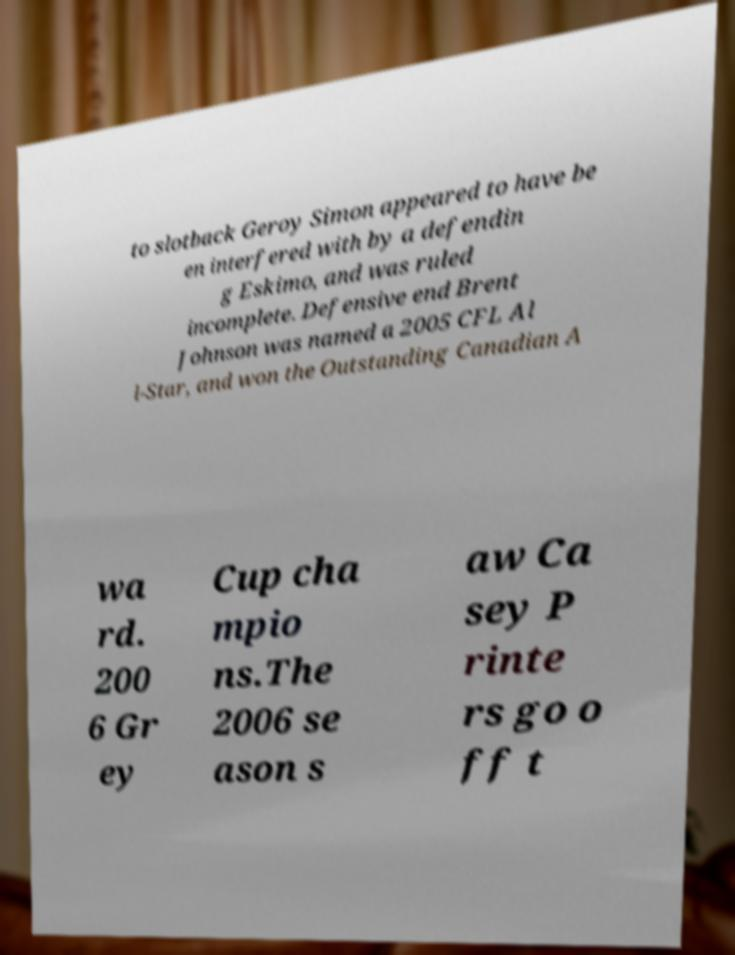Can you accurately transcribe the text from the provided image for me? to slotback Geroy Simon appeared to have be en interfered with by a defendin g Eskimo, and was ruled incomplete. Defensive end Brent Johnson was named a 2005 CFL Al l-Star, and won the Outstanding Canadian A wa rd. 200 6 Gr ey Cup cha mpio ns.The 2006 se ason s aw Ca sey P rinte rs go o ff t 